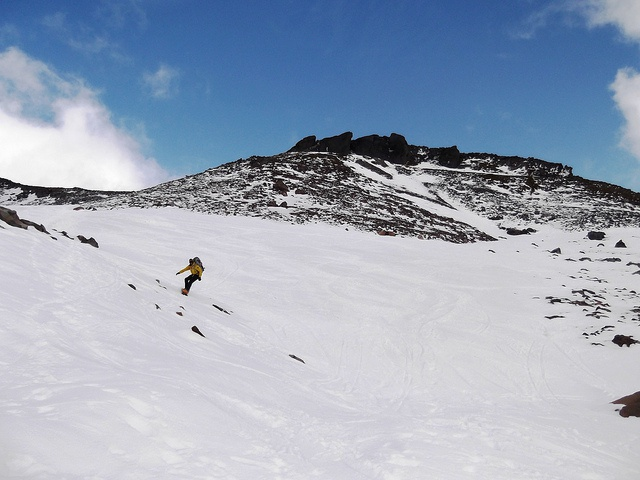Describe the objects in this image and their specific colors. I can see people in blue, black, olive, and gray tones, backpack in blue, gray, black, and darkgray tones, and snowboard in blue, black, maroon, and gray tones in this image. 